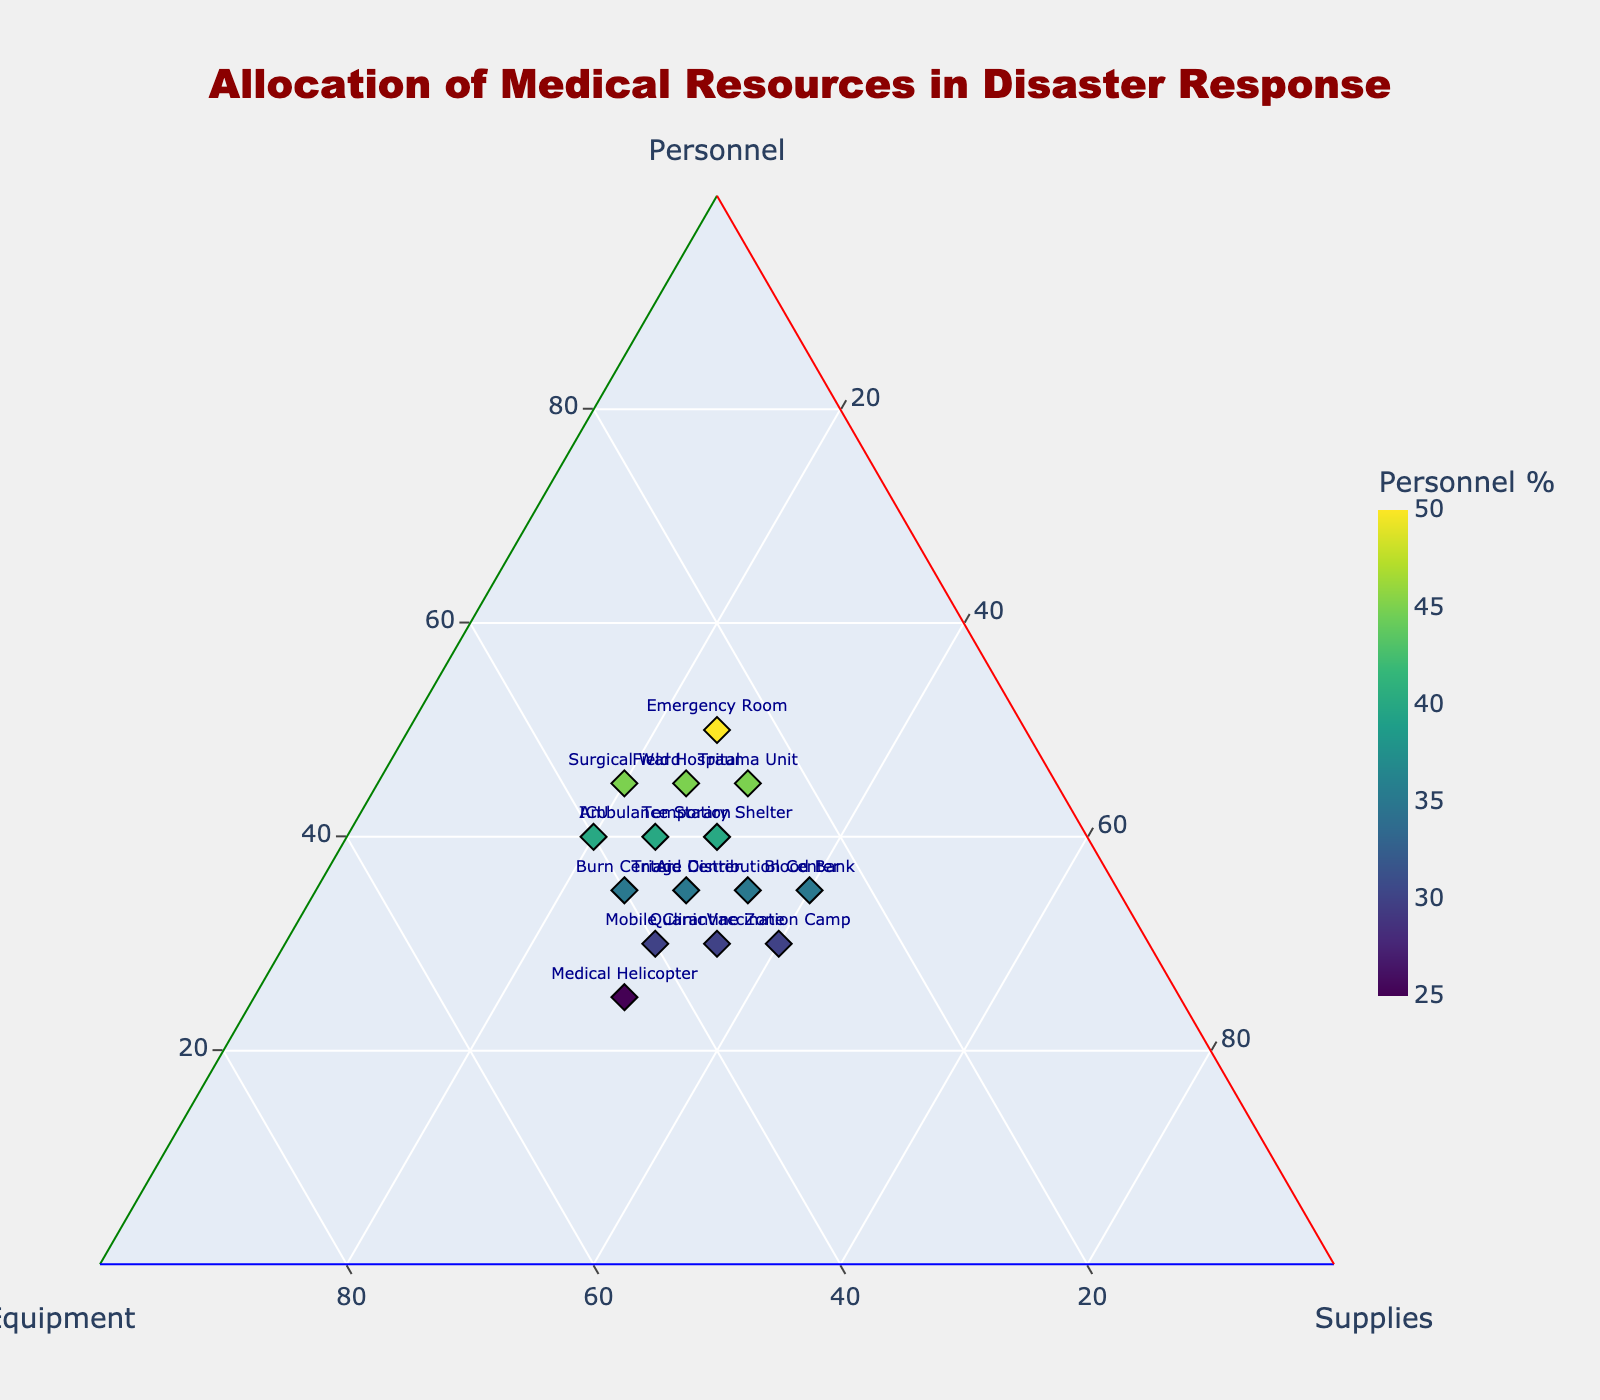What's the title of the figure? The title is typically found at the top of the figure, and in this case, it reads "Allocation of Medical Resources in Disaster Response" as specified in the code.
Answer: Allocation of Medical Resources in Disaster Response Which location has the highest proportion of Personnel? By identifying the data point farthest along the Personnel axis on the ternary plot, we see that the Emergency Room has 50% allocated to personnel, the highest among all locations.
Answer: Emergency Room How many locations have an equal allocation of Equipment and Supplies? Checking the data points where Equipment and Supplies values are identical, we find that the Mobile Clinic and Quarantine Zone both have 30% Equipment and 30% Supplies.
Answer: 2 Which location has the lowest percentage of Equipment allocated? Find the data point closest to the origin of the Equipment axis; the Blood Bank has the lowest allocation with 25% Equipment.
Answer: Blood Bank What is the average percentage allocation of Personnel across all locations? Sum all Personnel percentages and divide by the number of locations: (45 + 30 + 35 + 50 + 40 + 25 + 35 + 40 + 30 + 45 + 35 + 30 + 40 + 35 + 45) / 15. The total is 560, thus the average is 560/15 ≈ 37.33%.
Answer: 37.33% What proportion of Supplies does the Burn Center have compared to the Medical Helicopter? Subtract the Supplies percentage of the Medical Helicopter from the Burn Center: 25% (Burn Center) - 30% (Medical Helicopter) = -5%. The Burn Center has 5% less allocation in Supplies compared to the Medical Helicopter.
Answer: 5% less Which two locations are most similar in resource allocation? By visually identifying data points closely clustered in all three dimensions, the Field Hospital and Trauma Unit closely match, with Personnel/Equipment/Supplies of 45/30/25 and 45/25/30 respectively.
Answer: Field Hospital and Trauma Unit How many points represent locations with over 40% in Personnel? Count the data points with Personnel percentage greater than 40: Field Hospital, Emergency Room, Trauma Unit, and Surgical Ward, making it a total of 4 locations.
Answer: 4 